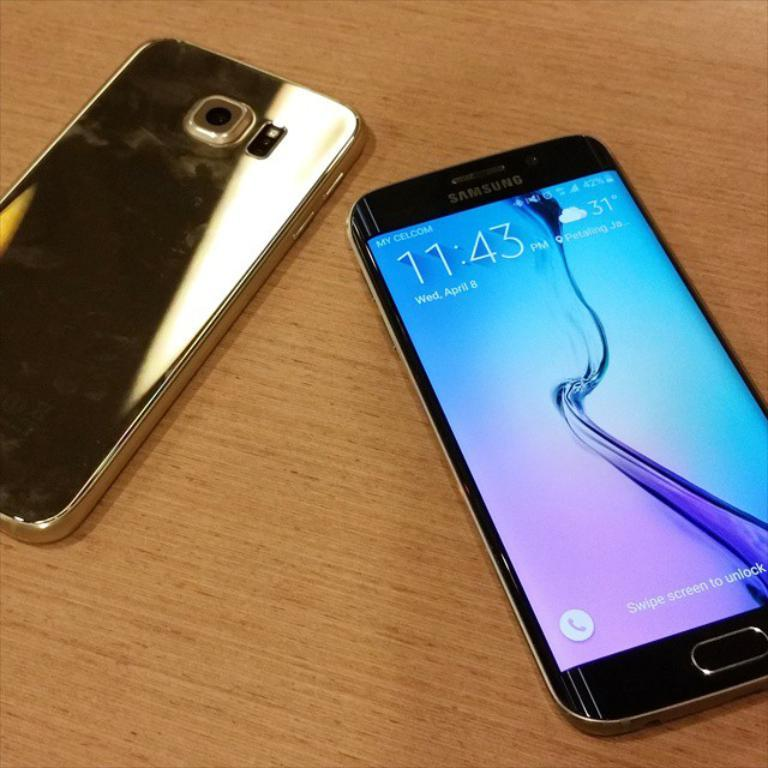<image>
Create a compact narrative representing the image presented. A cell phone displays the time on 11:43 and temperature of 31. 